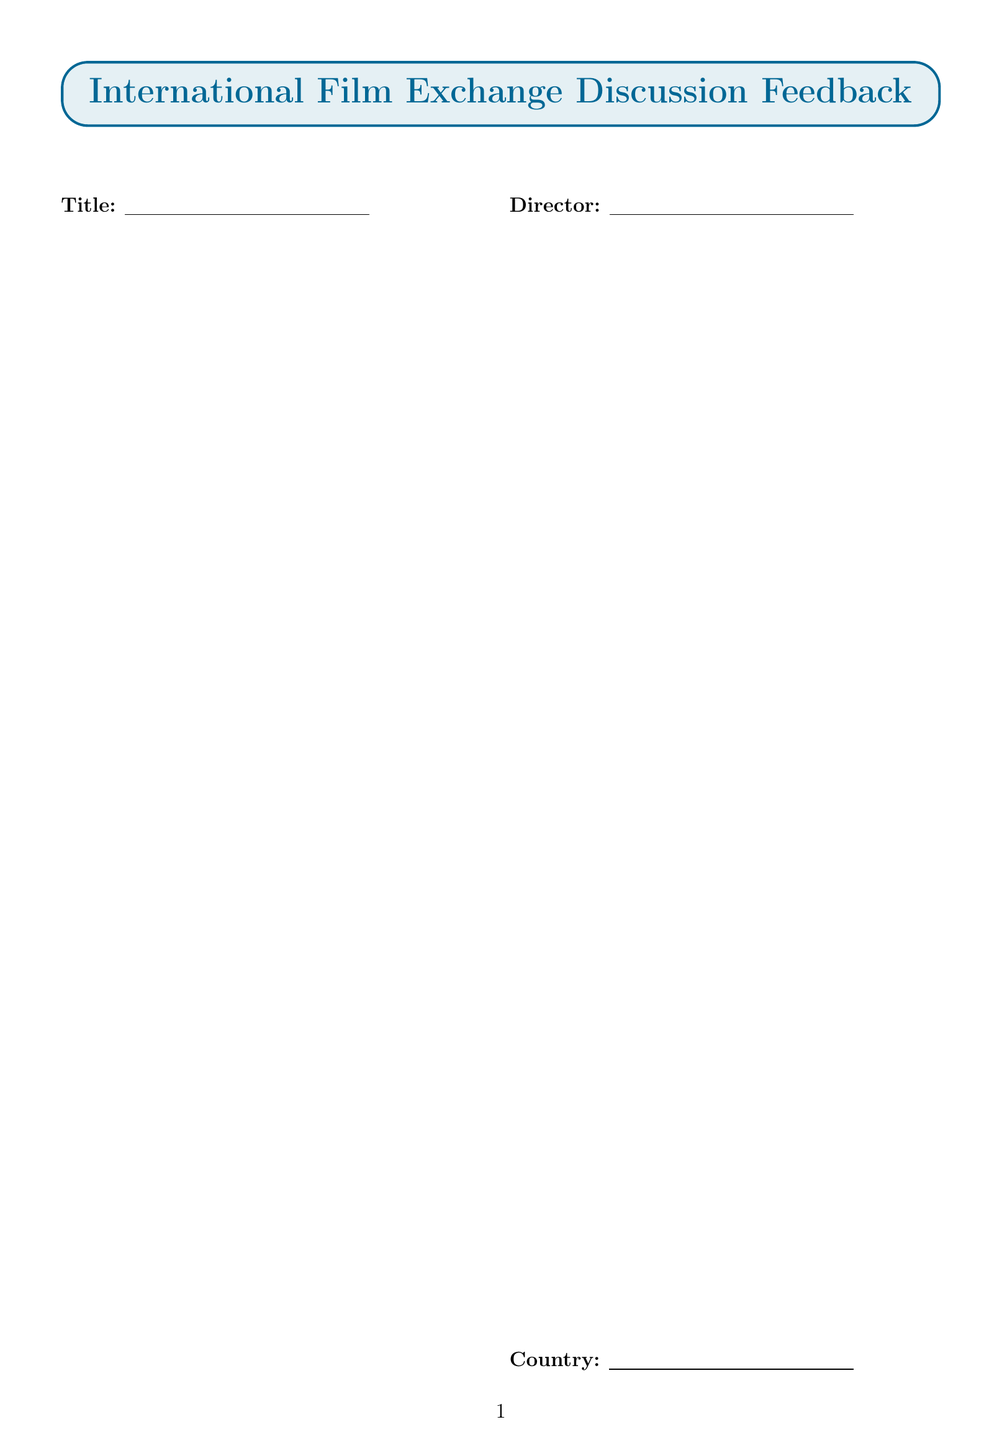What is the title of the film? The title is mentioned in the film details section of the document as a blank text field for input.
Answer: Text field Who is the director of the film? The director is provided in the film details section as a blank text field for input.
Answer: Text field What year was the film released? The year is expected to be filled in as a number in the film details section.
Answer: Number field What aspects are rated on a scale of 1 to 10? The rating scales include different aspects like Plot, Acting, Cinematography, Soundtrack, Cultural authenticity, and Overall enjoyment.
Answer: Six aspects How does this form collect language-focused feedback? The language focus section includes text areas for new vocabulary, idioms, and pronunciation challenges.
Answer: Text areas What is the maximum rating possible for overall experience? The overall experience section allows ratings up to 5 stars, indicating the highest satisfaction level.
Answer: 5 stars What kind of suggestions does the future exchange section request? The future exchange suggestions section requests input on genres, eras, and directors to explore.
Answer: Three types of suggestions What type of questions are included in the open-ended section? The open-ended questions are designed to gather insights on cultural and thematic elements of the film watched.
Answer: Cultural insights What is the purpose of the customs section in cultural insights? The customs section aims to capture interesting customs or traditions observed during the film, enhancing cultural understanding.
Answer: Describe customs 